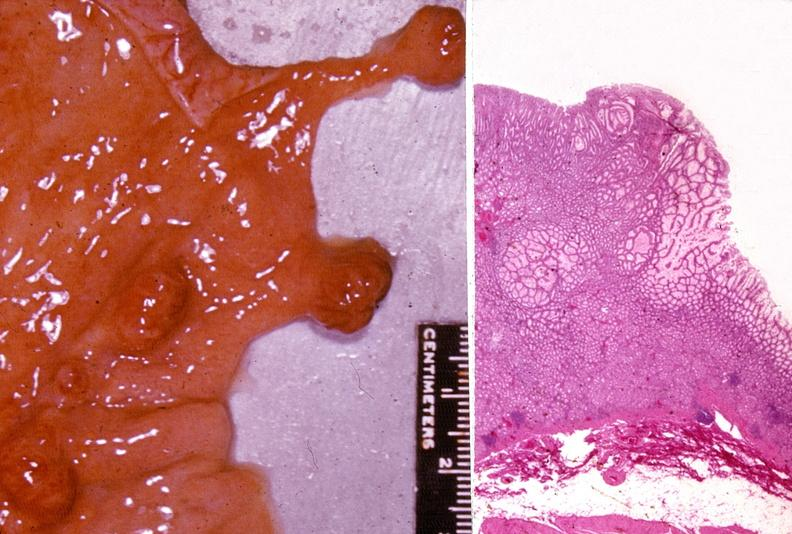where does this belong to?
Answer the question using a single word or phrase. Gastrointestinal system 